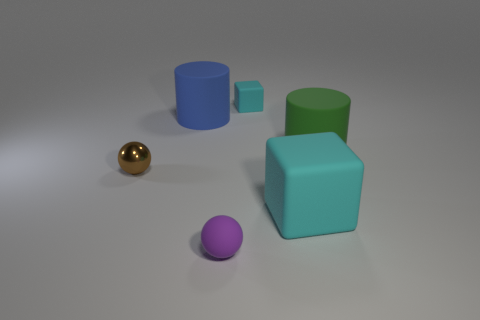Is the material of the small object that is left of the purple rubber ball the same as the large blue thing?
Give a very brief answer. No. Are there any cyan matte blocks that have the same size as the purple sphere?
Your answer should be very brief. Yes. Does the blue matte thing have the same shape as the cyan matte object behind the large cyan matte thing?
Provide a short and direct response. No. Are there any large blocks to the right of the small sphere behind the cyan thing that is in front of the small cyan matte object?
Offer a terse response. Yes. What size is the matte ball?
Keep it short and to the point. Small. What number of other objects are there of the same color as the large matte cube?
Provide a short and direct response. 1. There is a tiny object behind the metallic object; is its shape the same as the blue object?
Make the answer very short. No. There is another rubber thing that is the same shape as the large green thing; what is its color?
Keep it short and to the point. Blue. Is there anything else that is made of the same material as the tiny block?
Your answer should be very brief. Yes. What size is the other thing that is the same shape as the small brown shiny object?
Your response must be concise. Small. 